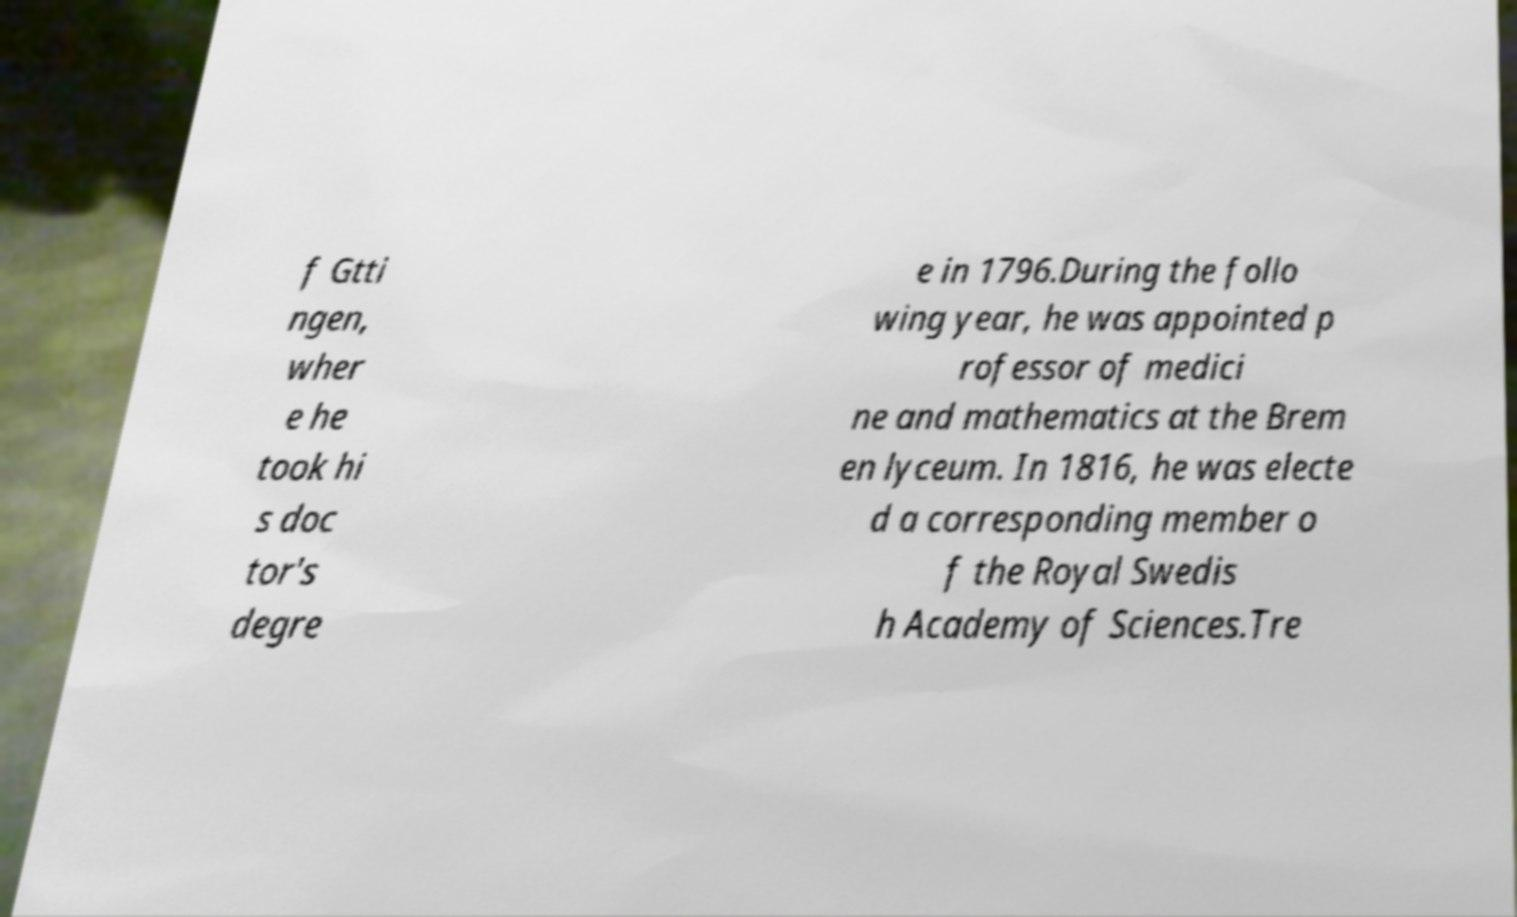Please identify and transcribe the text found in this image. f Gtti ngen, wher e he took hi s doc tor's degre e in 1796.During the follo wing year, he was appointed p rofessor of medici ne and mathematics at the Brem en lyceum. In 1816, he was electe d a corresponding member o f the Royal Swedis h Academy of Sciences.Tre 